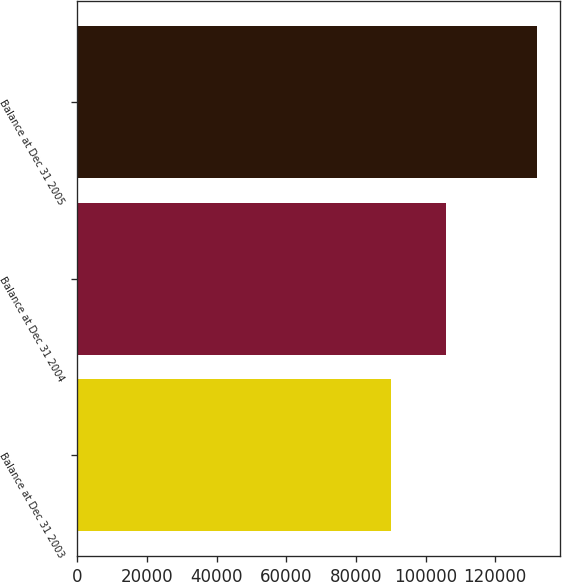Convert chart. <chart><loc_0><loc_0><loc_500><loc_500><bar_chart><fcel>Balance at Dec 31 2003<fcel>Balance at Dec 31 2004<fcel>Balance at Dec 31 2005<nl><fcel>90136<fcel>105934<fcel>132061<nl></chart> 